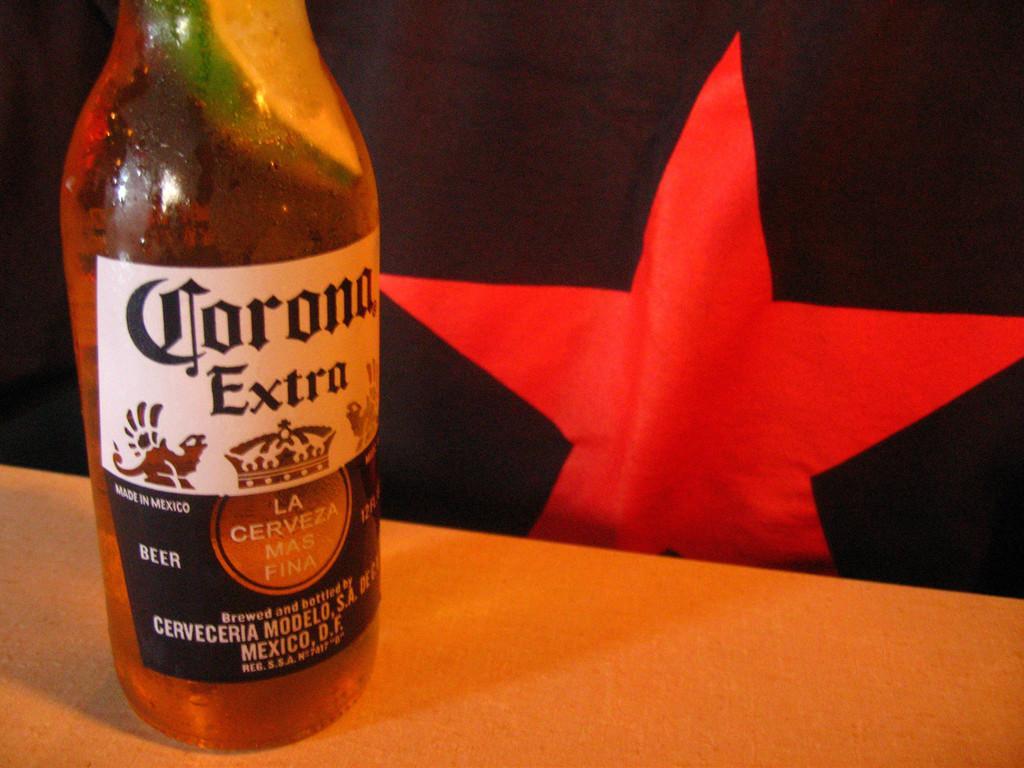Can you describe this image briefly? As we can see in the image there is a flag and bottle. 